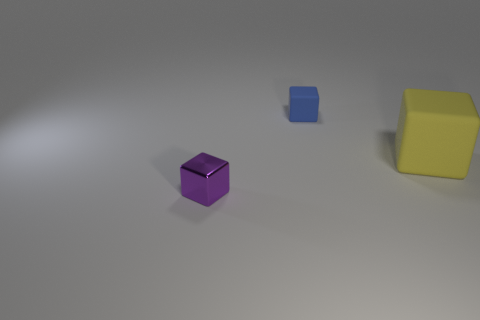What number of things are small cubes that are to the left of the small blue rubber thing or tiny blue matte objects?
Give a very brief answer. 2. Do the blue block and the yellow matte cube in front of the tiny matte thing have the same size?
Ensure brevity in your answer.  No. How many large objects are either cubes or matte blocks?
Your answer should be compact. 1. The tiny purple object is what shape?
Your answer should be compact. Cube. Is there a large yellow thing that has the same material as the blue thing?
Your answer should be very brief. Yes. Are there more small purple metallic cubes than things?
Provide a succinct answer. No. Is the material of the tiny blue cube the same as the big yellow block?
Your answer should be compact. Yes. What number of rubber objects are either large yellow blocks or big gray blocks?
Provide a succinct answer. 1. What is the color of the cube that is the same size as the blue thing?
Make the answer very short. Purple. How many other gray things are the same shape as the tiny rubber object?
Your answer should be compact. 0. 